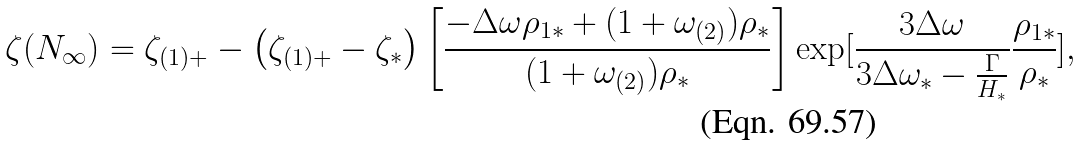Convert formula to latex. <formula><loc_0><loc_0><loc_500><loc_500>\zeta ( N _ { \infty } ) = \zeta _ { ( 1 ) + } - \left ( \zeta _ { ( 1 ) + } - \zeta _ { * } \right ) \left [ \frac { - \Delta \omega \rho _ { 1 * } + ( 1 + \omega _ { ( 2 ) } ) \rho _ { * } } { ( 1 + \omega _ { ( 2 ) } ) \rho _ { * } } \right ] \exp [ \frac { 3 \Delta \omega } { 3 \Delta \omega _ { * } - \frac { \Gamma } { H _ { * } } } \frac { \rho _ { 1 * } } { \rho _ { * } } ] ,</formula> 